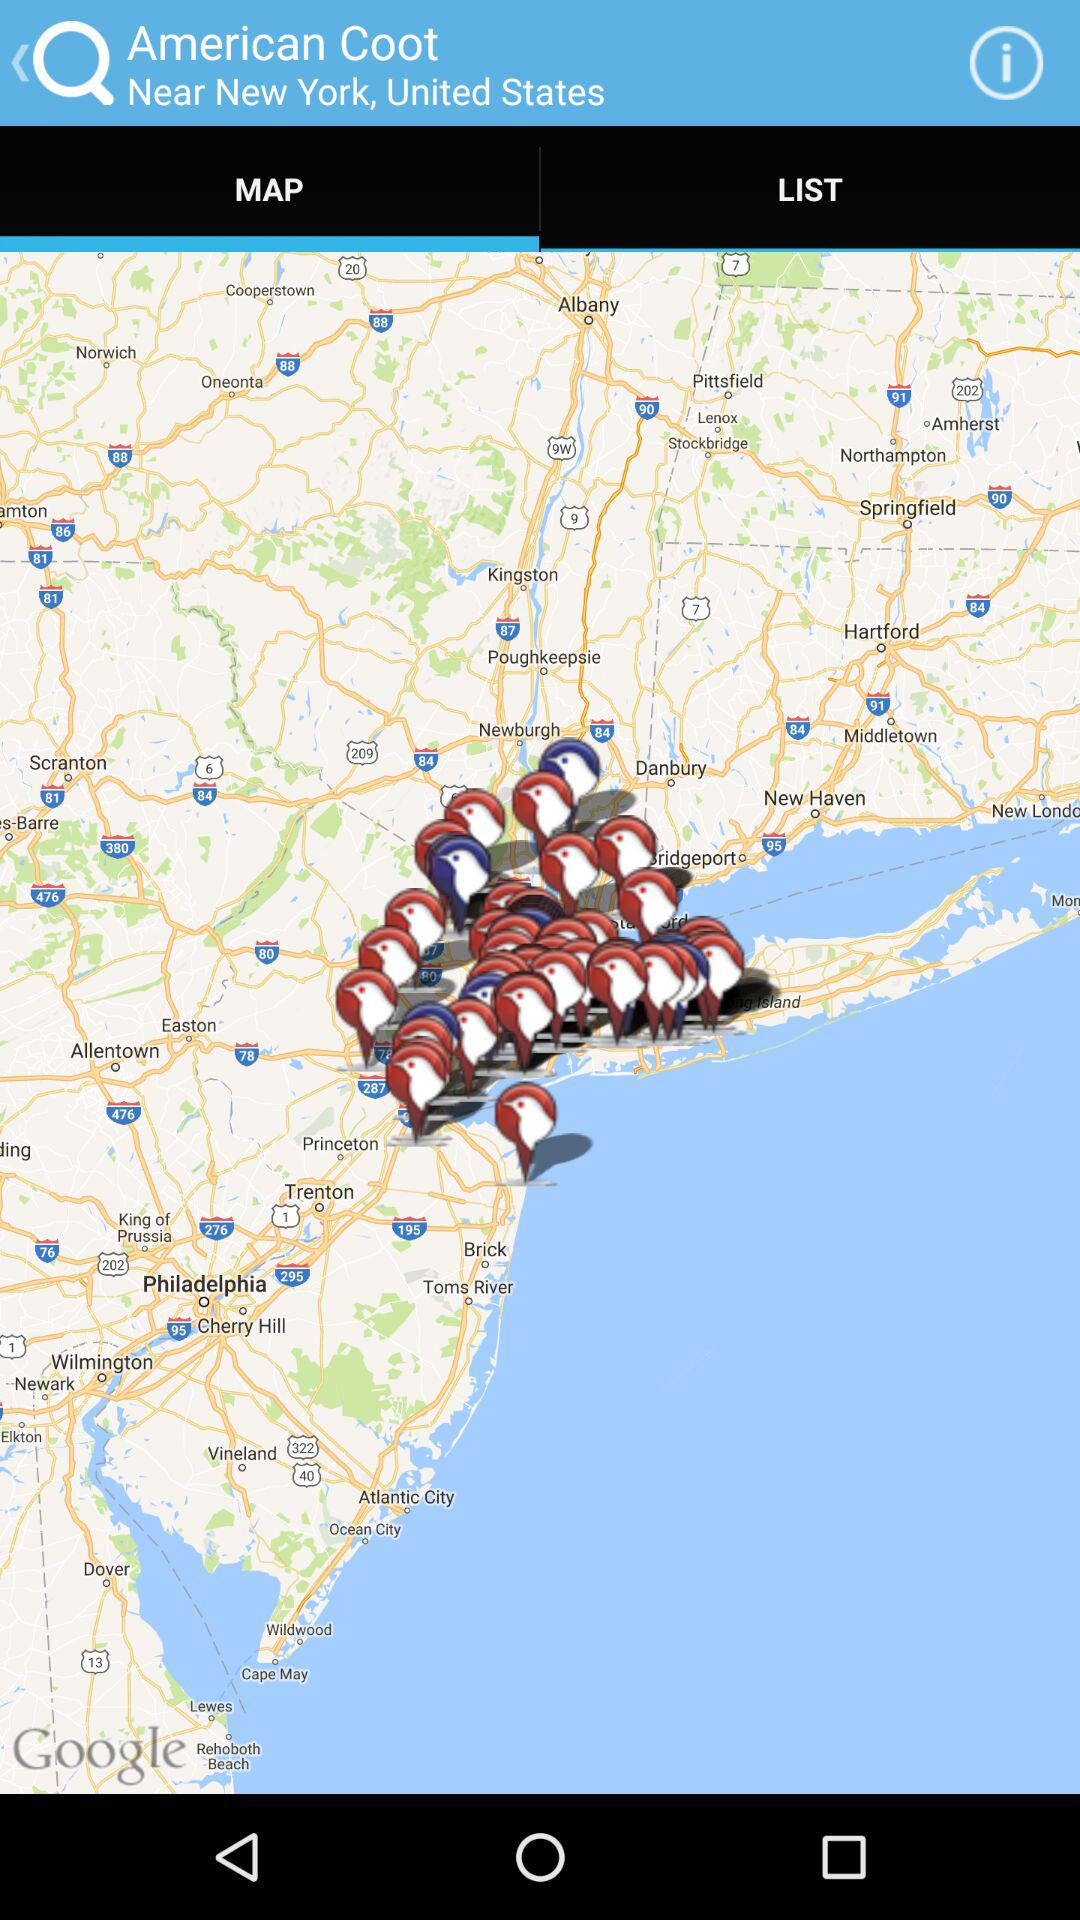What is the address of American Coot? American Coot's address is Near New York, United States. 